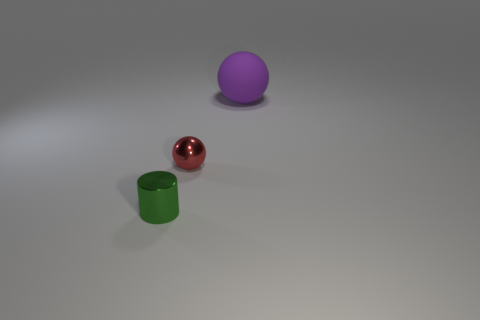Is there a small metallic cylinder that has the same color as the large object?
Offer a terse response. No. Do the small metallic thing behind the cylinder and the large rubber thing have the same shape?
Keep it short and to the point. Yes. How many red balls are the same size as the red shiny object?
Give a very brief answer. 0. What number of tiny shiny things are to the right of the sphere that is in front of the rubber thing?
Offer a terse response. 0. Does the ball on the left side of the big purple rubber ball have the same material as the large ball?
Keep it short and to the point. No. Do the small object right of the small green metallic thing and the tiny object to the left of the tiny red metallic sphere have the same material?
Offer a terse response. Yes. Are there more small objects on the right side of the metallic cylinder than red rubber balls?
Offer a very short reply. Yes. What color is the tiny thing that is on the right side of the tiny shiny thing in front of the red object?
Offer a very short reply. Red. There is a object that is the same size as the green metal cylinder; what shape is it?
Your response must be concise. Sphere. Are there an equal number of cylinders that are in front of the green metallic thing and brown objects?
Give a very brief answer. Yes. 